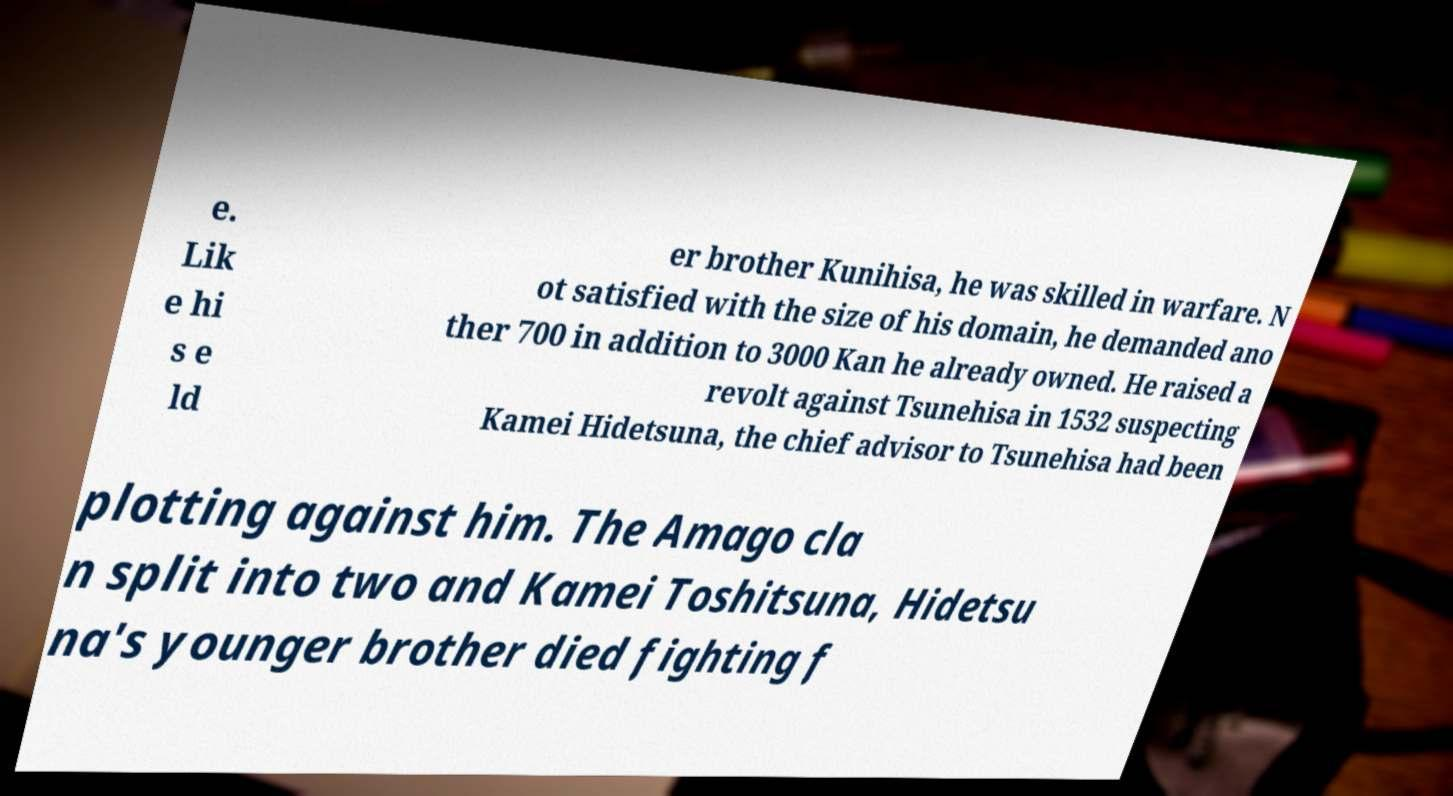Could you assist in decoding the text presented in this image and type it out clearly? e. Lik e hi s e ld er brother Kunihisa, he was skilled in warfare. N ot satisfied with the size of his domain, he demanded ano ther 700 in addition to 3000 Kan he already owned. He raised a revolt against Tsunehisa in 1532 suspecting Kamei Hidetsuna, the chief advisor to Tsunehisa had been plotting against him. The Amago cla n split into two and Kamei Toshitsuna, Hidetsu na's younger brother died fighting f 